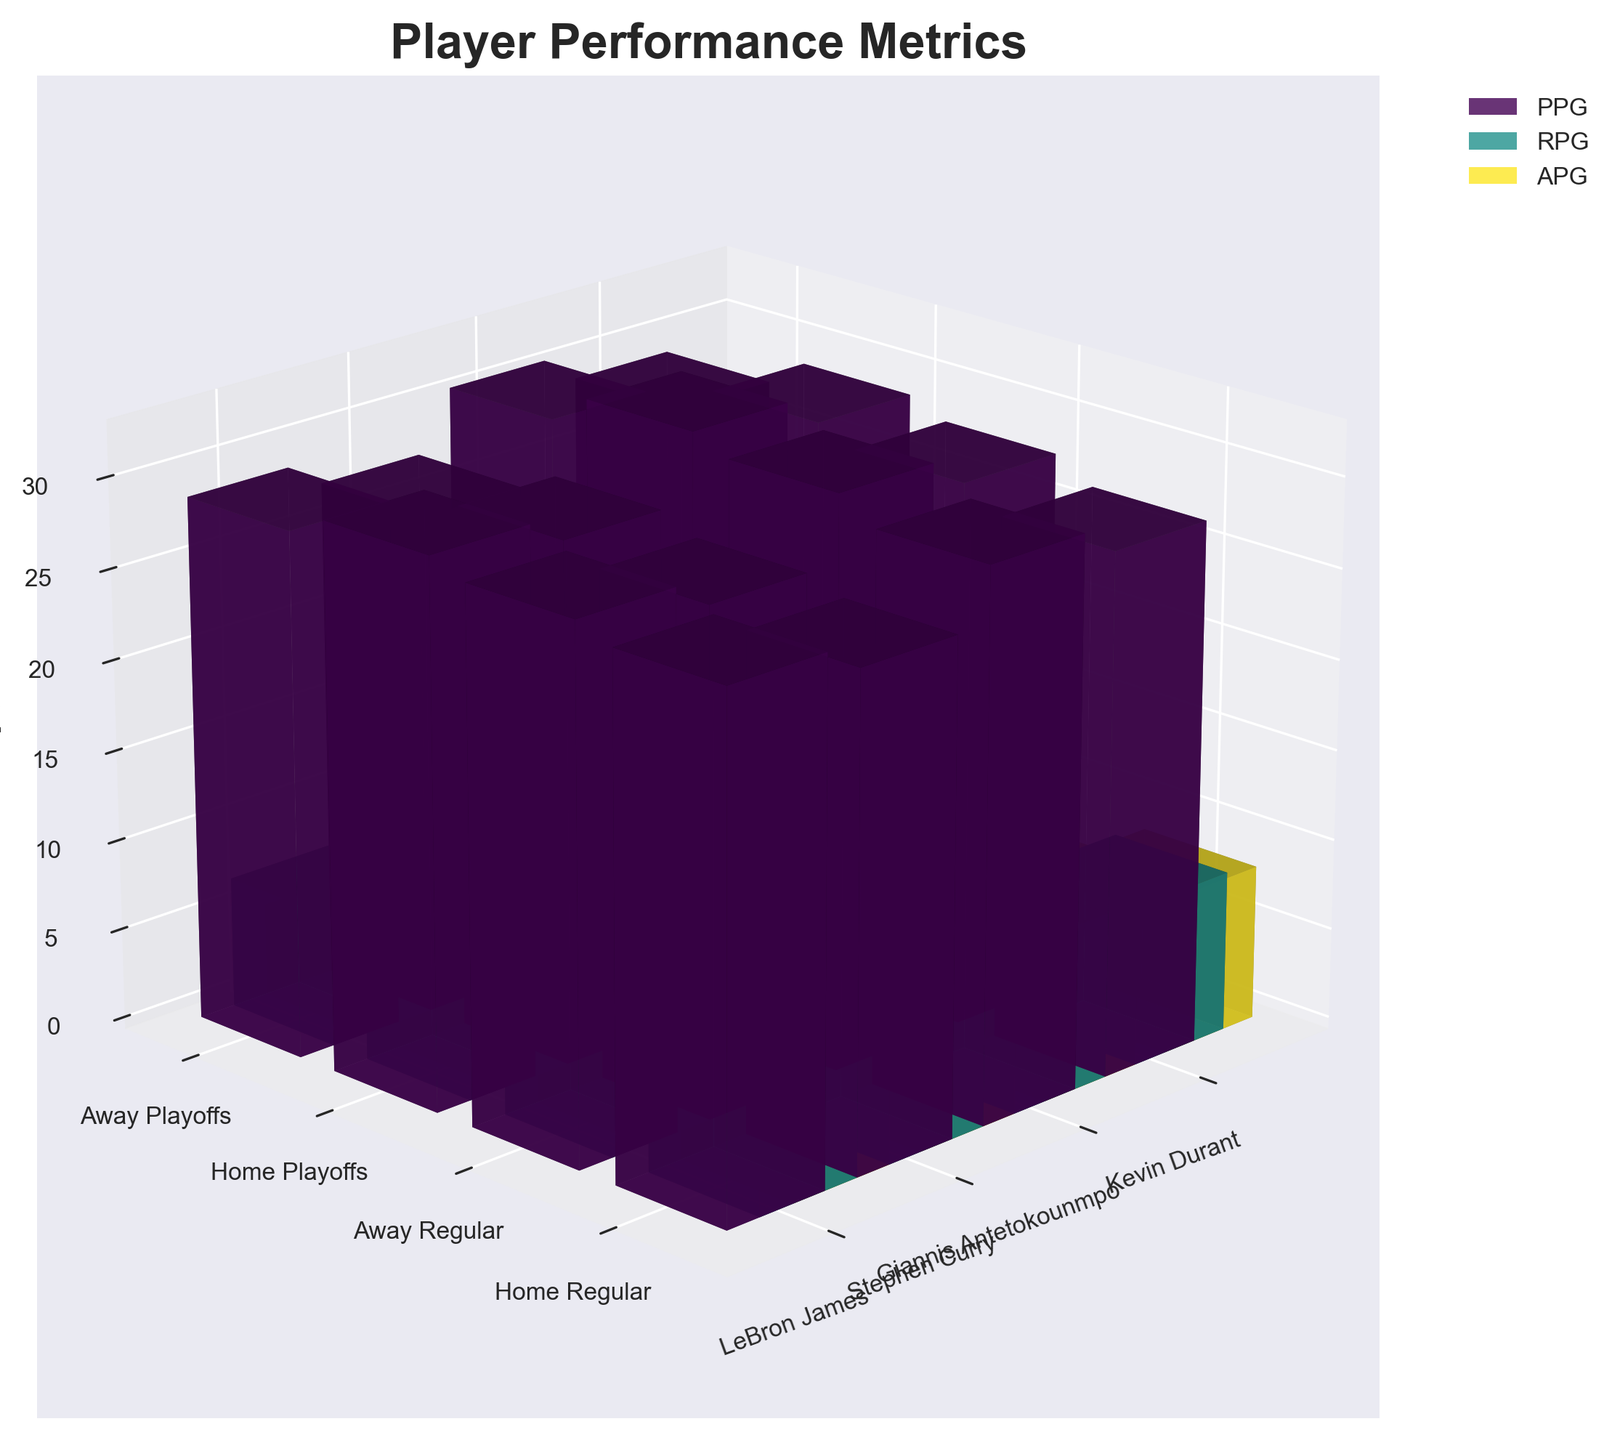What's the title of the figure? The title of the figure is displayed at the top and reads "Player Performance Metrics"
Answer: Player Performance Metrics How many players are compared in the figure? The x-axis is labeled with player names, and there are four unique player names: LeBron James, Stephen Curry, Giannis Antetokounmpo, and Kevin Durant
Answer: 4 What metric is represented by the vertical (z-axis) of the figure? The z-axis is labeled "Value," indicating it represents the performance metric values for Points Per Game (PPG), Rebounds Per Game (RPG), and Assists Per Game (APG)
Answer: Value Which player has the highest Points Per Game (PPG) in Home Playoffs? First identify the scenario "Home Playoffs" on the y-axis, then locate the bars for each metric. The tallest bar in Home Playoffs for PPG is associated with Giannis Antetokounmpo
Answer: Giannis Antetokounmpo Which scenario shows the highest average Rebounds Per Game (RPG) across all players? Calculate the average RPG for each scenario by summing the RPG values and dividing by the number of players for that scenario. Home Playoffs (9.1 + 6.2 + 13.2 + 8.1)/4 has the highest average.
Answer: Home Playoffs What is the difference in Assists Per Game (APG) for Kevin Durant between Home Regular and Away Regular scenarios? For Kevin Durant, the APG values are 5.1 in Home Regular and 4.8 in Away Regular. The difference is calculated as 5.1 - 4.8 = 0.3
Answer: 0.3 Who has a greater increase in Points Per Game (PPG) from Home Regular to Home Playoffs, LeBron James or Stephen Curry? For LeBron James: 30.2 - 28.5 = 1.7. For Stephen Curry: 31.5 - 29.3 = 2.2. Compare these increases: 2.2 > 1.7, so Stephen Curry has a greater increase
Answer: Stephen Curry How do the Assists Per Game (APG) in Away Regular compare for Stephen Curry and Giannis Antetokounmpo? In the Away Regular scenario, Stephen Curry has 6.1 APG and Giannis Antetokounmpo has 5.6 APG. Stephen Curry's value is higher than Giannis Antetokounmpo's
Answer: Stephen Curry has higher APG Which player has the smallest variance in Rebounds Per Game (RPG) across all scenarios? Calculate the variance for each player's RPG values across the four scenarios and compare them. LeBron James: Var(7.9, 7.6, 9.1, 8.8); Stephen Curry: Var(5.5, 5.2, 6.2, 5.9); Giannis Antetokounmpo: Var(11.8, 11.2, 13.2, 12.5); Kevin Durant: Var(7.2, 6.8, 8.1, 7.6). Stephen Curry has the smallest variance.
Answer: Stephen Curry Which player has the highest average Points Per Game (PPG) across all scenarios? Calculate the average PPG for each player by summing their PPG values for all four scenarios and dividing by four. Giannis Antetokounmpo: (30.1 + 28.7 + 32.4 + 30.8)/4 has the highest average.
Answer: Giannis Antetokounmpo 